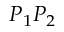<formula> <loc_0><loc_0><loc_500><loc_500>P _ { 1 } P _ { 2 }</formula> 